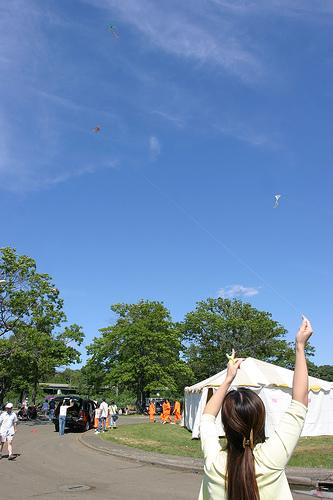Is there any vehicle in the image? If yes, then what is its color and where it is parked? Yes, there is a black vehicle parked on the road. What is the woman wearing in the image and what is she doing with her arms? The woman is wearing a white shirt with her arms lifted, flying a kite. How many kites are there in the sky, and what are their colors? There are three kites in the sky, and one of them is white. Describe the position of the man wearing a cap in the image. The man wearing a cap is located at the left bottom corner of the image. Identify the weather condition in the image and describe the sky. The weather is clear with a hazy blue sky. State the location of the storm drain in the image. The storm drain is at the bottom right side of the image. What is the main activity happening in the image? A woman is flying a kite in the park. List the colors of the objects in the image. Blue sky, white clouds, various color kites, white tent, black car, grey road, green leaves, white shirt, green and brown grass. Count the number of people in the image and their gender. There are four men and one woman in the image. What outdoor setting is depicted in this image?  The image represents a park with people, kites, a tent, trees, and a car. 